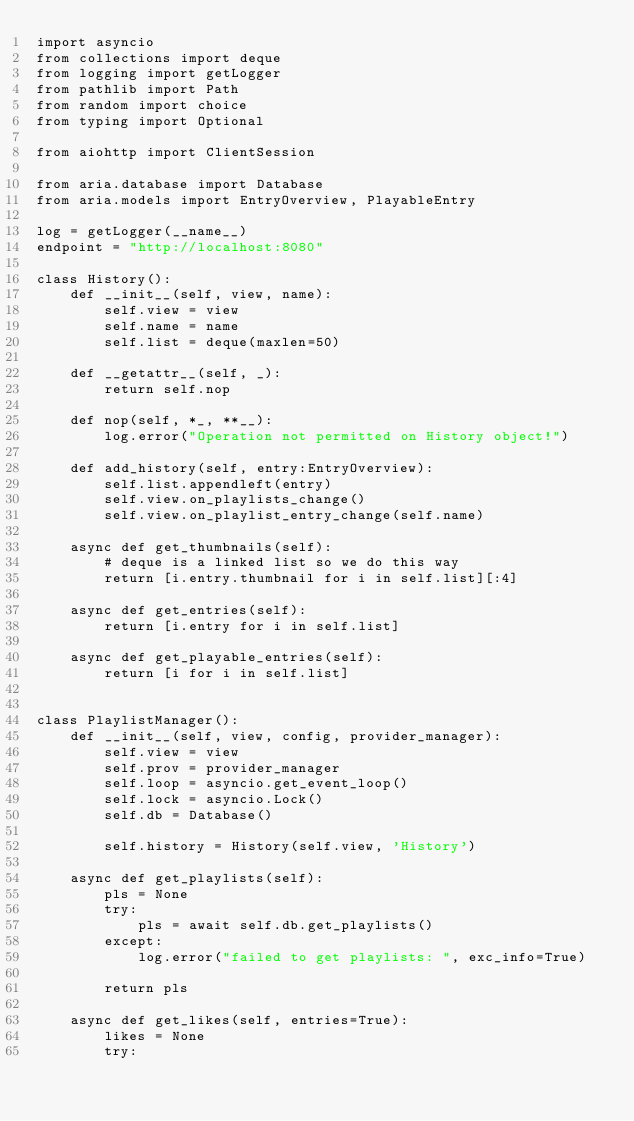Convert code to text. <code><loc_0><loc_0><loc_500><loc_500><_Python_>import asyncio
from collections import deque
from logging import getLogger
from pathlib import Path
from random import choice
from typing import Optional

from aiohttp import ClientSession

from aria.database import Database
from aria.models import EntryOverview, PlayableEntry

log = getLogger(__name__)
endpoint = "http://localhost:8080"

class History():
    def __init__(self, view, name):
        self.view = view
        self.name = name
        self.list = deque(maxlen=50)

    def __getattr__(self, _):
        return self.nop

    def nop(self, *_, **__):
        log.error("Operation not permitted on History object!")

    def add_history(self, entry:EntryOverview):
        self.list.appendleft(entry)
        self.view.on_playlists_change()
        self.view.on_playlist_entry_change(self.name)

    async def get_thumbnails(self):
        # deque is a linked list so we do this way
        return [i.entry.thumbnail for i in self.list][:4]

    async def get_entries(self):
        return [i.entry for i in self.list]

    async def get_playable_entries(self):
        return [i for i in self.list]


class PlaylistManager():
    def __init__(self, view, config, provider_manager):
        self.view = view
        self.prov = provider_manager
        self.loop = asyncio.get_event_loop()
        self.lock = asyncio.Lock()
        self.db = Database()

        self.history = History(self.view, 'History')

    async def get_playlists(self):
        pls = None
        try:
            pls = await self.db.get_playlists()
        except:
            log.error("failed to get playlists: ", exc_info=True)

        return pls

    async def get_likes(self, entries=True):
        likes = None
        try:</code> 